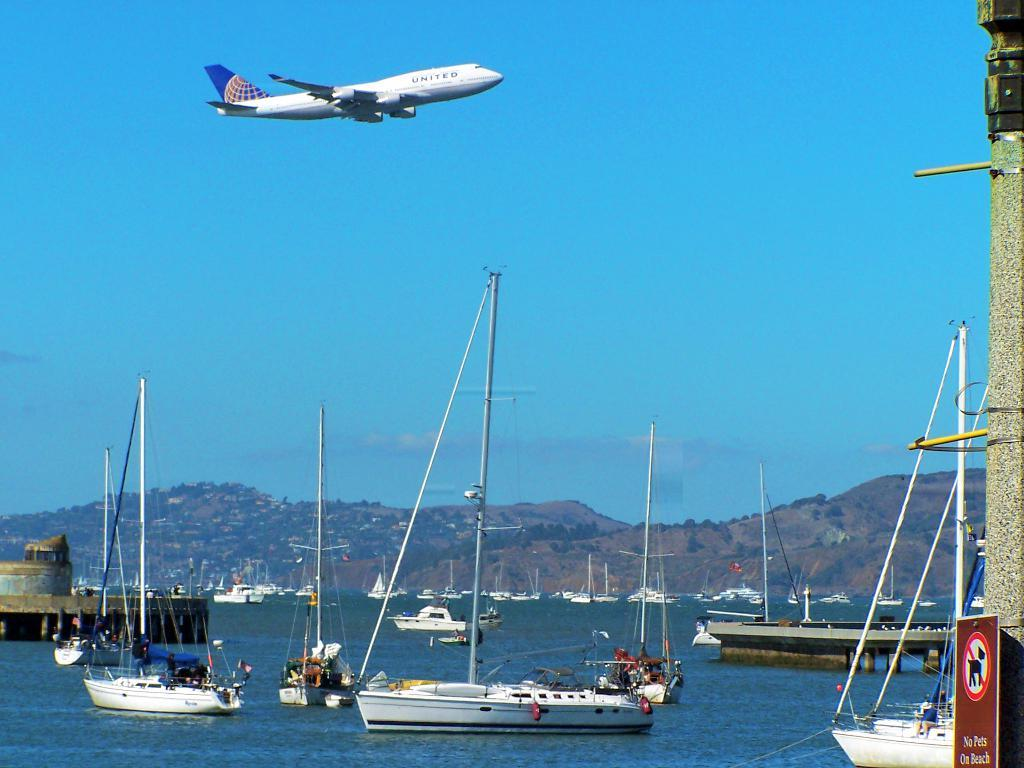<image>
Give a short and clear explanation of the subsequent image. A bay with sailboats boats and a United passenger jet flying above. 